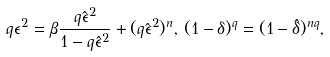<formula> <loc_0><loc_0><loc_500><loc_500>q \epsilon ^ { 2 } = \beta \frac { q \hat { \epsilon } ^ { 2 } } { 1 - q \hat { \epsilon } ^ { 2 } } + ( q \hat { \epsilon } ^ { 2 } ) ^ { n } , \, ( 1 - \delta ) ^ { q } = ( 1 - \hat { \delta } ) ^ { n q } ,</formula> 